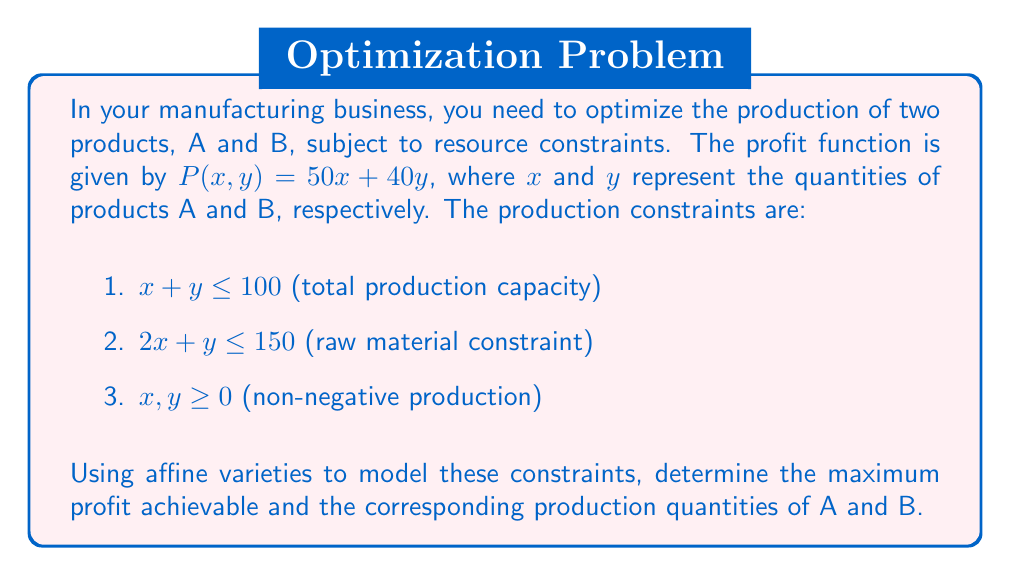Can you answer this question? Let's approach this step-by-step using affine varieties:

1) First, we model the constraints as affine varieties:
   $$V_1 = \{(x,y,z) \in \mathbb{A}^3 : x + y - z = 0, z \leq 100\}$$
   $$V_2 = \{(x,y,z) \in \mathbb{A}^3 : 2x + y - z = 0, z \leq 150\}$$
   $$V_3 = \{(x,y) \in \mathbb{A}^2 : x \geq 0, y \geq 0\}$$

2) The feasible region is the intersection of these varieties:
   $$V = V_1 \cap V_2 \cap V_3$$

3) To maximize profit, we need to find the point in $V$ that maximizes $P(x,y) = 50x + 40y$.

4) In the $xy$-plane, the constraints form a polygon. The optimal solution will be at one of the vertices of this polygon.

5) The vertices are:
   - $(0,0)$: intersection of $x=0$ and $y=0$
   - $(0,100)$: intersection of $x=0$ and $x+y=100$
   - $(50,50)$: intersection of $x+y=100$ and $2x+y=150$
   - $(75,0)$: intersection of $y=0$ and $2x+y=150$

6) Evaluating $P(x,y)$ at these points:
   - $P(0,0) = 0$
   - $P(0,100) = 4000$
   - $P(50,50) = 4500$
   - $P(75,0) = 3750$

7) The maximum profit is achieved at $(50,50)$, which corresponds to producing 50 units of product A and 50 units of product B.

8) The maximum profit is $P(50,50) = 50(50) + 40(50) = 4500$.
Answer: Maximum profit: $4500; Production: 50 units of A, 50 units of B 